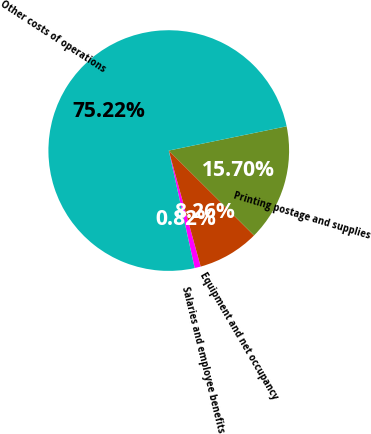<chart> <loc_0><loc_0><loc_500><loc_500><pie_chart><fcel>Salaries and employee benefits<fcel>Equipment and net occupancy<fcel>Printing postage and supplies<fcel>Other costs of operations<nl><fcel>0.82%<fcel>8.26%<fcel>15.7%<fcel>75.23%<nl></chart> 